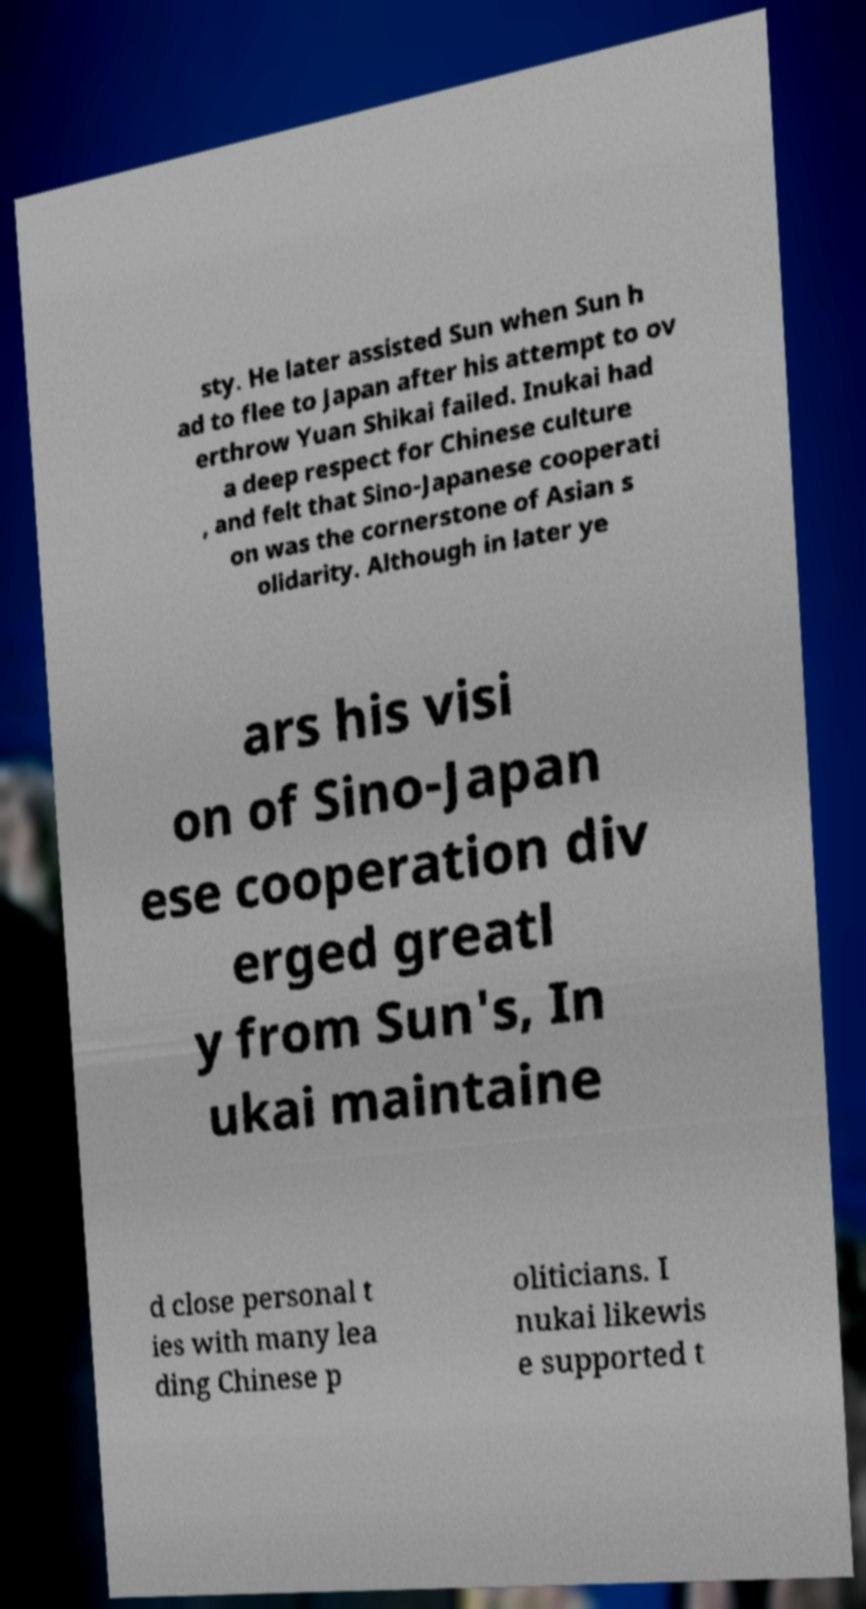Can you accurately transcribe the text from the provided image for me? sty. He later assisted Sun when Sun h ad to flee to Japan after his attempt to ov erthrow Yuan Shikai failed. Inukai had a deep respect for Chinese culture , and felt that Sino-Japanese cooperati on was the cornerstone of Asian s olidarity. Although in later ye ars his visi on of Sino-Japan ese cooperation div erged greatl y from Sun's, In ukai maintaine d close personal t ies with many lea ding Chinese p oliticians. I nukai likewis e supported t 